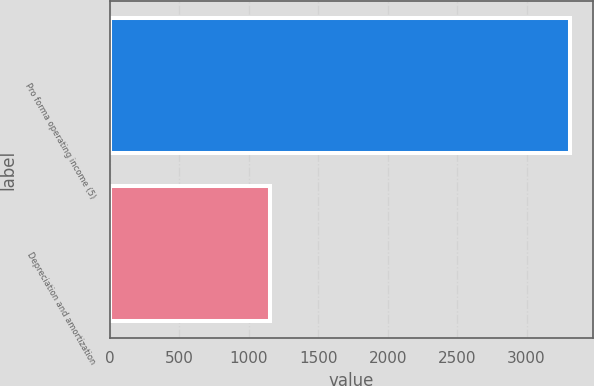Convert chart. <chart><loc_0><loc_0><loc_500><loc_500><bar_chart><fcel>Pro forma operating income (5)<fcel>Depreciation and amortization<nl><fcel>3312.5<fcel>1150.4<nl></chart> 